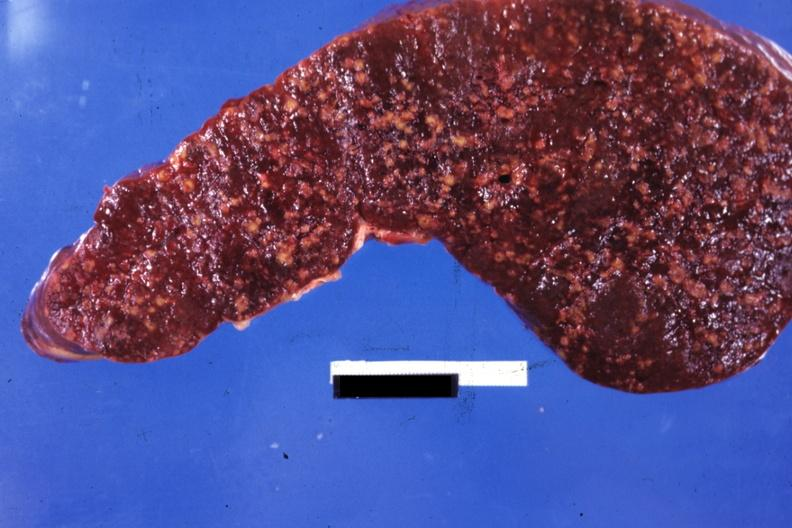s purulent sinusitis present?
Answer the question using a single word or phrase. No 